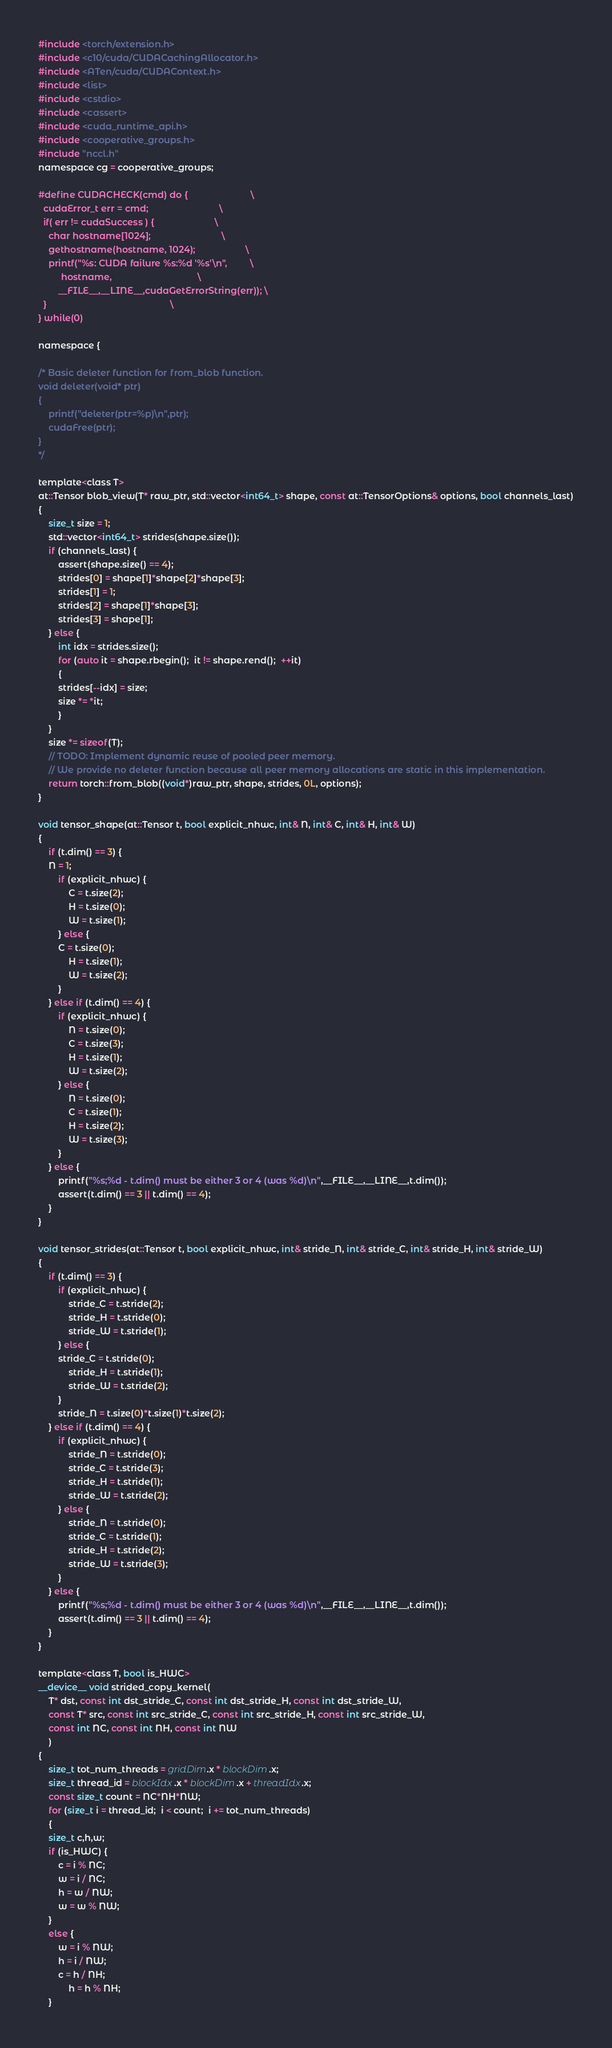<code> <loc_0><loc_0><loc_500><loc_500><_Cuda_>#include <torch/extension.h>
#include <c10/cuda/CUDACachingAllocator.h>
#include <ATen/cuda/CUDAContext.h>
#include <list>
#include <cstdio>
#include <cassert>
#include <cuda_runtime_api.h>
#include <cooperative_groups.h>
#include "nccl.h"
namespace cg = cooperative_groups;

#define CUDACHECK(cmd) do {                         \
  cudaError_t err = cmd;                            \
  if( err != cudaSuccess ) {                        \
    char hostname[1024];                            \
    gethostname(hostname, 1024);                    \
    printf("%s: CUDA failure %s:%d '%s'\n",         \
         hostname,                                  \
        __FILE__,__LINE__,cudaGetErrorString(err)); \
  }                                                 \
} while(0)

namespace {

/* Basic deleter function for from_blob function.
void deleter(void* ptr)
{
    printf("deleter(ptr=%p)\n",ptr);
    cudaFree(ptr);
}
*/

template<class T>
at::Tensor blob_view(T* raw_ptr, std::vector<int64_t> shape, const at::TensorOptions& options, bool channels_last)
{
    size_t size = 1;
    std::vector<int64_t> strides(shape.size());
    if (channels_last) {
        assert(shape.size() == 4);
        strides[0] = shape[1]*shape[2]*shape[3];
        strides[1] = 1;
        strides[2] = shape[1]*shape[3];
        strides[3] = shape[1];
    } else {
        int idx = strides.size();
        for (auto it = shape.rbegin();  it != shape.rend();  ++it)
        {
	    strides[--idx] = size;
	    size *= *it;
        }
    }
    size *= sizeof(T);
    // TODO: Implement dynamic reuse of pooled peer memory.
    // We provide no deleter function because all peer memory allocations are static in this implementation.
    return torch::from_blob((void*)raw_ptr, shape, strides, 0L, options);
}

void tensor_shape(at::Tensor t, bool explicit_nhwc, int& N, int& C, int& H, int& W)
{
    if (t.dim() == 3) {
	N = 1;
        if (explicit_nhwc) {
            C = t.size(2);
            H = t.size(0);
            W = t.size(1);
        } else {
	    C = t.size(0);
    	    H = t.size(1);
    	    W = t.size(2);
        }
    } else if (t.dim() == 4) {
        if (explicit_nhwc) {
            N = t.size(0);
            C = t.size(3);
            H = t.size(1);
            W = t.size(2);
        } else {
            N = t.size(0);
            C = t.size(1);
            H = t.size(2);
            W = t.size(3);
        }
    } else {
        printf("%s;%d - t.dim() must be either 3 or 4 (was %d)\n",__FILE__,__LINE__,t.dim());
        assert(t.dim() == 3 || t.dim() == 4);
    }
}

void tensor_strides(at::Tensor t, bool explicit_nhwc, int& stride_N, int& stride_C, int& stride_H, int& stride_W)
{
    if (t.dim() == 3) {
        if (explicit_nhwc) {
            stride_C = t.stride(2);
            stride_H = t.stride(0);
            stride_W = t.stride(1);
        } else {
	    stride_C = t.stride(0);
    	    stride_H = t.stride(1);
    	    stride_W = t.stride(2);
        }
        stride_N = t.size(0)*t.size(1)*t.size(2);
    } else if (t.dim() == 4) {
        if (explicit_nhwc) {
            stride_N = t.stride(0);
            stride_C = t.stride(3);
            stride_H = t.stride(1);
            stride_W = t.stride(2);
        } else {
            stride_N = t.stride(0);
            stride_C = t.stride(1);
            stride_H = t.stride(2);
            stride_W = t.stride(3);
        }
    } else {
        printf("%s;%d - t.dim() must be either 3 or 4 (was %d)\n",__FILE__,__LINE__,t.dim());
        assert(t.dim() == 3 || t.dim() == 4);
    }
}

template<class T, bool is_HWC>
__device__ void strided_copy_kernel(
	T* dst, const int dst_stride_C, const int dst_stride_H, const int dst_stride_W, 
	const T* src, const int src_stride_C, const int src_stride_H, const int src_stride_W, 
	const int NC, const int NH, const int NW
	)
{
    size_t tot_num_threads = gridDim.x * blockDim.x;
    size_t thread_id = blockIdx.x * blockDim.x + threadIdx.x;
    const size_t count = NC*NH*NW;
    for (size_t i = thread_id;  i < count;  i += tot_num_threads)
    {
	size_t c,h,w;
	if (is_HWC) {
	    c = i % NC;
	    w = i / NC;
	    h = w / NW;
	    w = w % NW;
	}
	else {
	    w = i % NW;
	    h = i / NW;
	    c = h / NH;
            h = h % NH;
	}</code> 